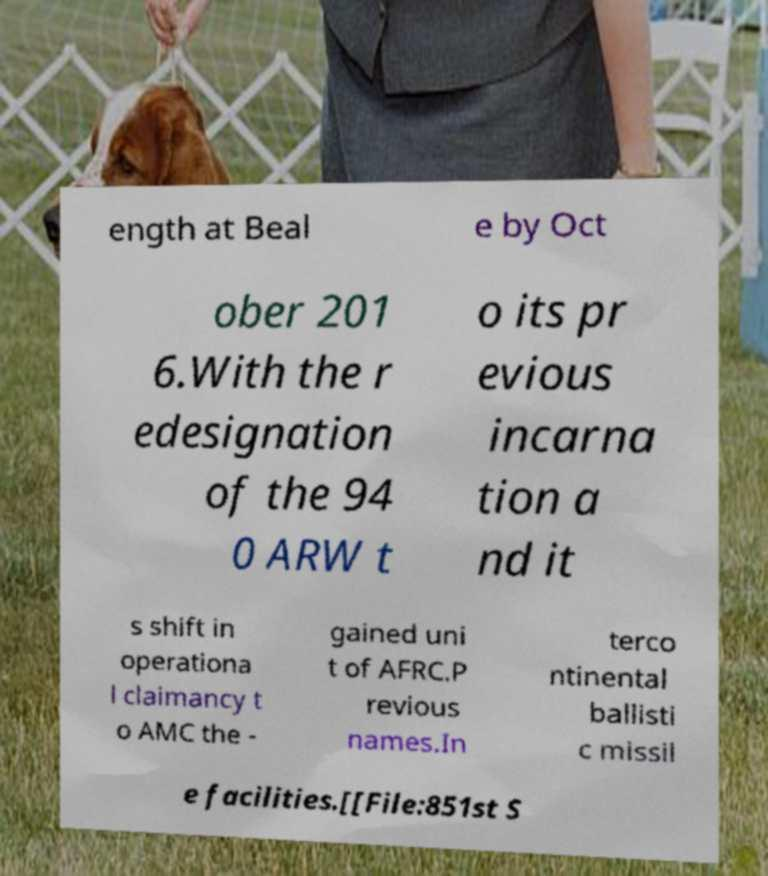Please read and relay the text visible in this image. What does it say? ength at Beal e by Oct ober 201 6.With the r edesignation of the 94 0 ARW t o its pr evious incarna tion a nd it s shift in operationa l claimancy t o AMC the - gained uni t of AFRC.P revious names.In terco ntinental ballisti c missil e facilities.[[File:851st S 